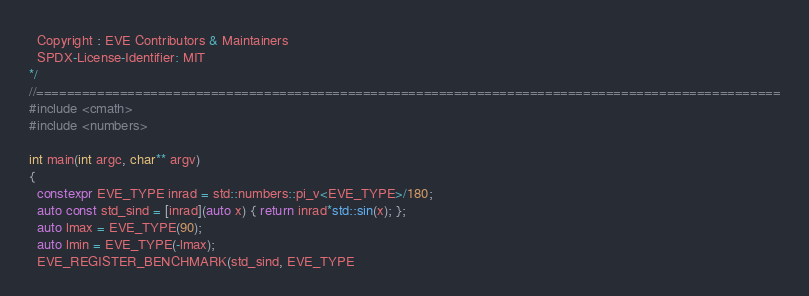Convert code to text. <code><loc_0><loc_0><loc_500><loc_500><_C++_>  Copyright : EVE Contributors & Maintainers
  SPDX-License-Identifier: MIT
*/
//==================================================================================================
#include <cmath>
#include <numbers>

int main(int argc, char** argv)
{
  constexpr EVE_TYPE inrad = std::numbers::pi_v<EVE_TYPE>/180;
  auto const std_sind = [inrad](auto x) { return inrad*std::sin(x); };
  auto lmax = EVE_TYPE(90);
  auto lmin = EVE_TYPE(-lmax);
  EVE_REGISTER_BENCHMARK(std_sind, EVE_TYPE</code> 